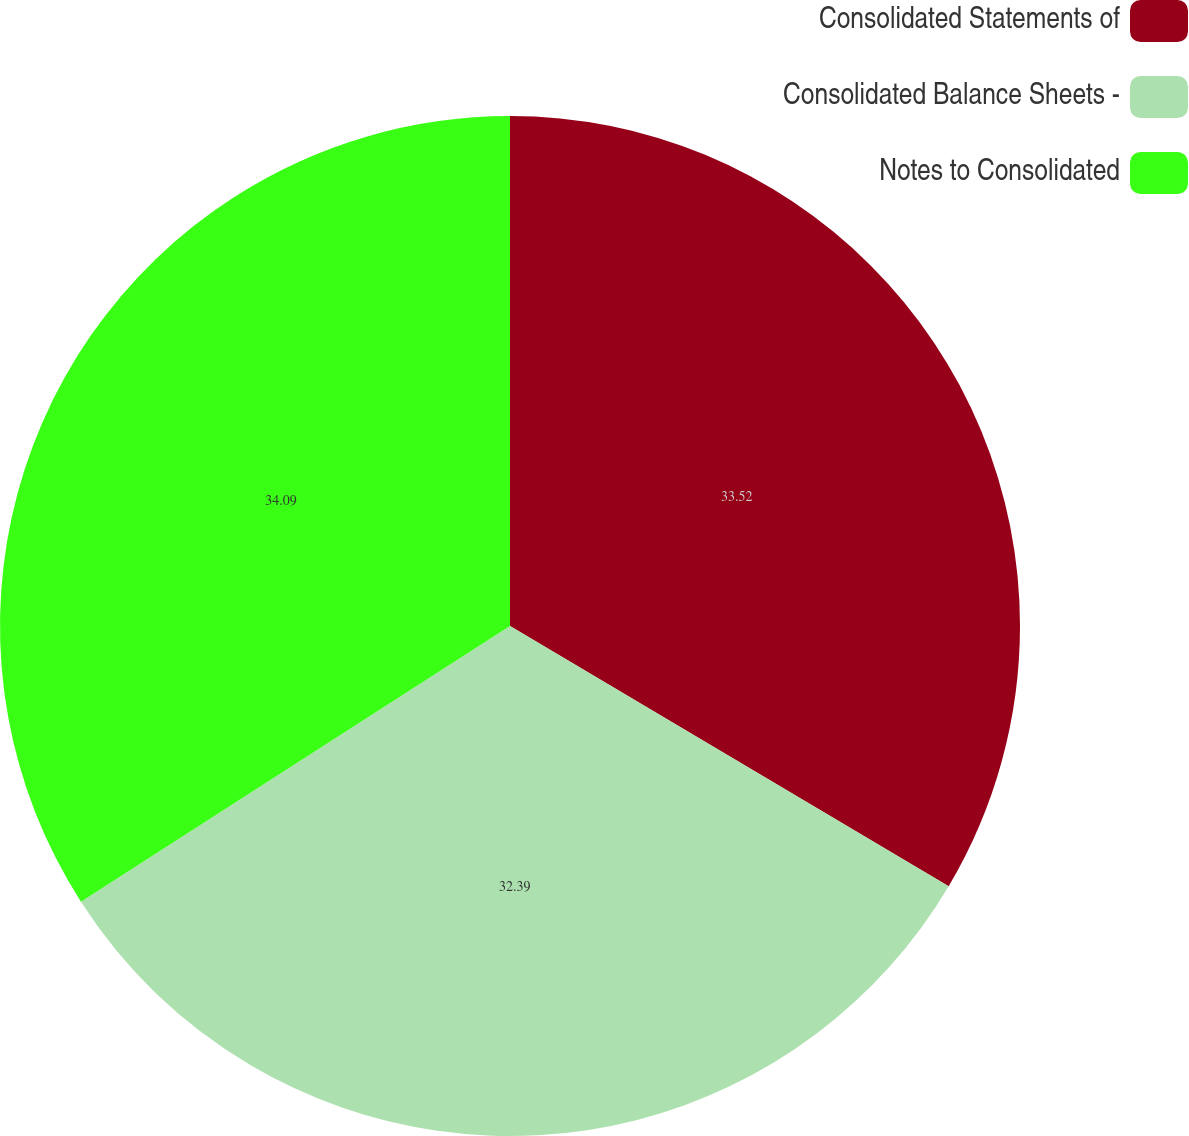<chart> <loc_0><loc_0><loc_500><loc_500><pie_chart><fcel>Consolidated Statements of<fcel>Consolidated Balance Sheets -<fcel>Notes to Consolidated<nl><fcel>33.52%<fcel>32.39%<fcel>34.09%<nl></chart> 